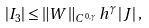<formula> <loc_0><loc_0><loc_500><loc_500>\left | I _ { 3 } \right | \leq \left \| W \right \| _ { C ^ { 0 , \gamma } } h ^ { \gamma } \left | J \right | ,</formula> 